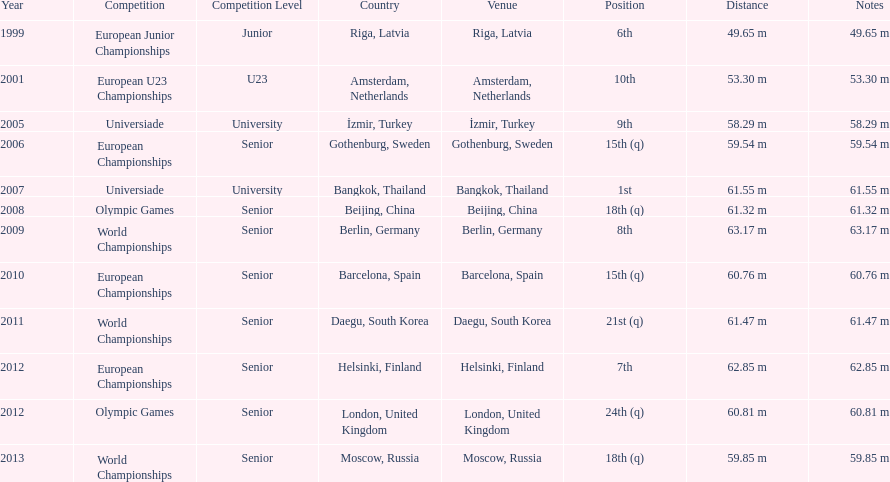What are the total number of times european junior championships is listed as the competition? 1. Could you parse the entire table? {'header': ['Year', 'Competition', 'Competition Level', 'Country', 'Venue', 'Position', 'Distance', 'Notes'], 'rows': [['1999', 'European Junior Championships', 'Junior', 'Riga, Latvia', 'Riga, Latvia', '6th', '49.65 m', '49.65 m'], ['2001', 'European U23 Championships', 'U23', 'Amsterdam, Netherlands', 'Amsterdam, Netherlands', '10th', '53.30 m', '53.30 m'], ['2005', 'Universiade', 'University', 'İzmir, Turkey', 'İzmir, Turkey', '9th', '58.29 m', '58.29 m'], ['2006', 'European Championships', 'Senior', 'Gothenburg, Sweden', 'Gothenburg, Sweden', '15th (q)', '59.54 m', '59.54 m'], ['2007', 'Universiade', 'University', 'Bangkok, Thailand', 'Bangkok, Thailand', '1st', '61.55 m', '61.55 m'], ['2008', 'Olympic Games', 'Senior', 'Beijing, China', 'Beijing, China', '18th (q)', '61.32 m', '61.32 m'], ['2009', 'World Championships', 'Senior', 'Berlin, Germany', 'Berlin, Germany', '8th', '63.17 m', '63.17 m'], ['2010', 'European Championships', 'Senior', 'Barcelona, Spain', 'Barcelona, Spain', '15th (q)', '60.76 m', '60.76 m'], ['2011', 'World Championships', 'Senior', 'Daegu, South Korea', 'Daegu, South Korea', '21st (q)', '61.47 m', '61.47 m'], ['2012', 'European Championships', 'Senior', 'Helsinki, Finland', 'Helsinki, Finland', '7th', '62.85 m', '62.85 m'], ['2012', 'Olympic Games', 'Senior', 'London, United Kingdom', 'London, United Kingdom', '24th (q)', '60.81 m', '60.81 m'], ['2013', 'World Championships', 'Senior', 'Moscow, Russia', 'Moscow, Russia', '18th (q)', '59.85 m', '59.85 m']]} 